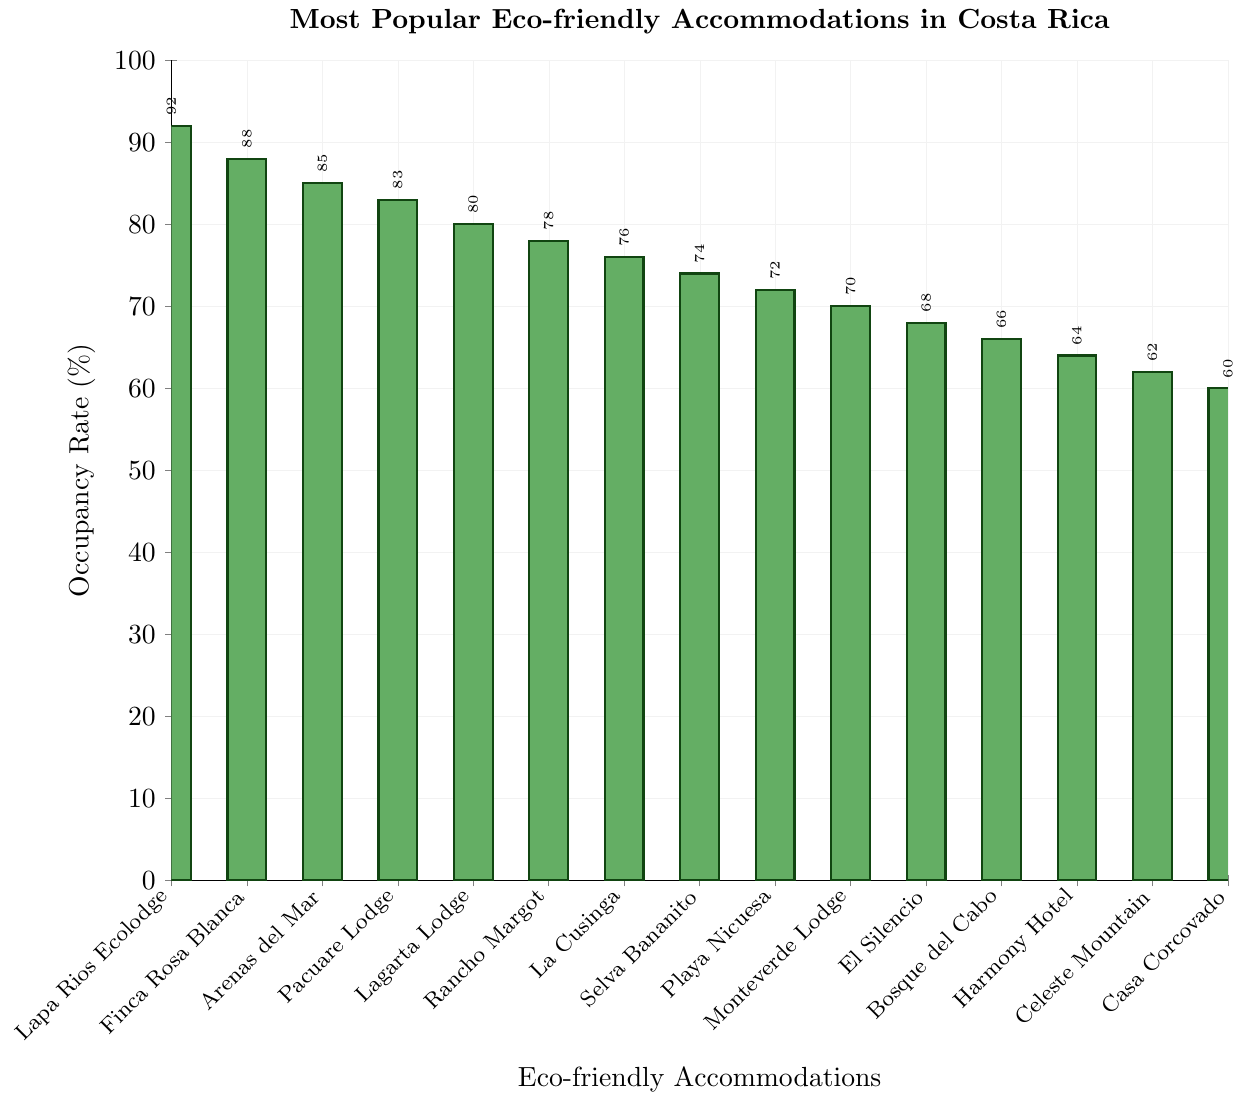Which accommodation has the highest occupancy rate? By looking at the height of the bars, Lapa Rios Ecolodge has the tallest bar indicating the highest occupancy rate.
Answer: Lapa Rios Ecolodge What is the occupancy rate difference between Lapa Rios Ecolodge and Casa Corcovado Jungle Lodge? The figure shows Lapa Rios Ecolodge has a 92% occupancy rate, and Casa Corcovado Jungle Lodge has a 60% occupancy rate. Subtracting Casa Corcovado's rate from Lapa Rios' gives 92 - 60.
Answer: 32% How many accommodations have an occupancy rate of 70% or more? Counting the bars with heights indicating 70% or above: there are 10 such bars (from Lapa Rios Ecolodge to Monteverde Lodge & Gardens).
Answer: 10 Which accommodation is more popular, Rancho Margot or Selva Bananito Lodge? Comparing the heights of the bars for Rancho Margot (78%) and Selva Bananito Lodge (74%), Rancho Margot has a taller bar.
Answer: Rancho Margot What's the average occupancy rate for the top three accommodations? Adding the occupancy rates of the top three accommodations: 92% (Lapa Rios Ecolodge), 88% (Finca Rosa Blanca Coffee Plantation Resort), and 85% (Arenas del Mar Beachfront & Rainforest Resort). Total = 265%. Dividing by 3 gives the average: 265 / 3.
Answer: 88.3% What is the median occupancy rate for all the accommodations listed? To find the median, list the occupancy rates in order: 60, 62, 64, 66, 68, 70, 72, 74, 76, 78, 80, 83, 85, 88, and 92. The median is the middle value, which is the 8th value in this list.
Answer: 74% Which two accommodations have the closest occupancy rates? Looking at the difference between adjacent occupancy rates, the closest are Finca Rosa Blanca Coffee Plantation Resort and Arenas del Mar Beachfront & Rainforest Resort with rates of 88% and 85%, respectively. The difference is 3%.
Answer: Finca Rosa Blanca Coffee Plantation Resort and Arenas del Mar Beachfront & Rainforest Resort What is the total occupancy rate for Playa Nicuesa Rainforest Lodge, Monteverde Lodge & Gardens, and El Silencio Lodge & Spa? Summing their occupancy rates: 72% (Playa Nicuesa), 70% (Monteverde), and 68% (El Silencio), gives a total of 72 + 70 + 68.
Answer: 210% How much higher is the occupancy rate of Lagarta Lodge compared to Harmony Hotel? Lagarta Lodge has an occupancy rate of 80%, and Harmony Hotel has an occupancy rate of 64%. Subtracting Harmony Hotel's rate from Lagarta Lodge's rate gives 80 - 64.
Answer: 16% Which accommodations have occupancy rates below 65%? Looking at the bars showing occupancy rates less than 65%, the accommodations are Harmony Hotel (64%), Celeste Mountain Lodge (62%), and Casa Corcovado Jungle Lodge (60%).
Answer: Harmony Hotel, Celeste Mountain Lodge, Casa Corcovado Jungle Lodge 